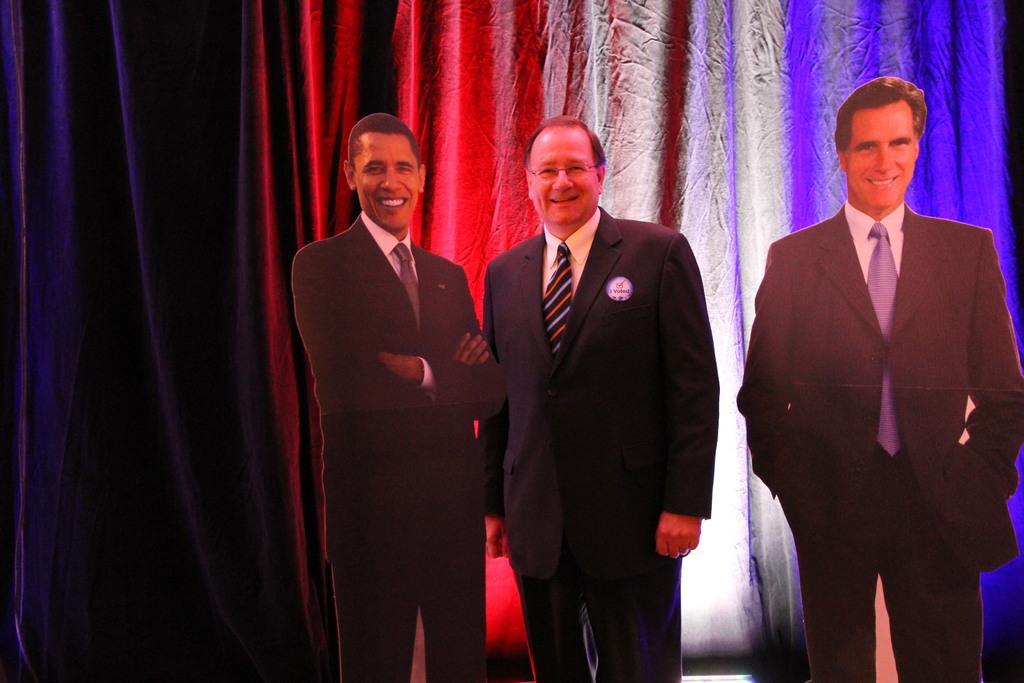Can you describe this image briefly? In this image I can see a person standing in between two boards. In the background there is a curtain. 